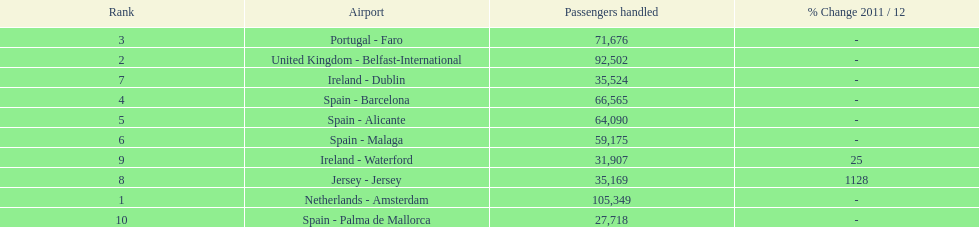Where is the most popular destination for passengers leaving london southend airport? Netherlands - Amsterdam. 